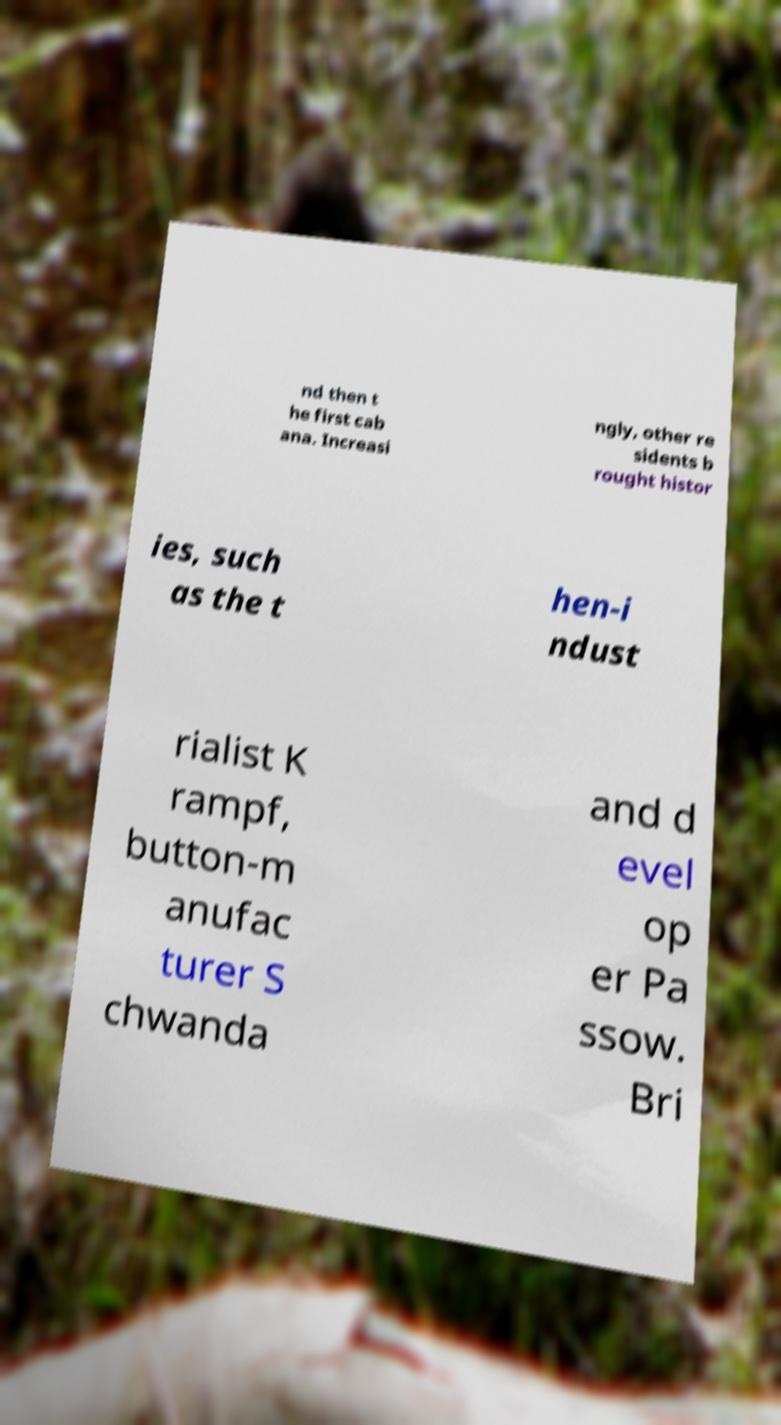What messages or text are displayed in this image? I need them in a readable, typed format. nd then t he first cab ana. Increasi ngly, other re sidents b rought histor ies, such as the t hen-i ndust rialist K rampf, button-m anufac turer S chwanda and d evel op er Pa ssow. Bri 